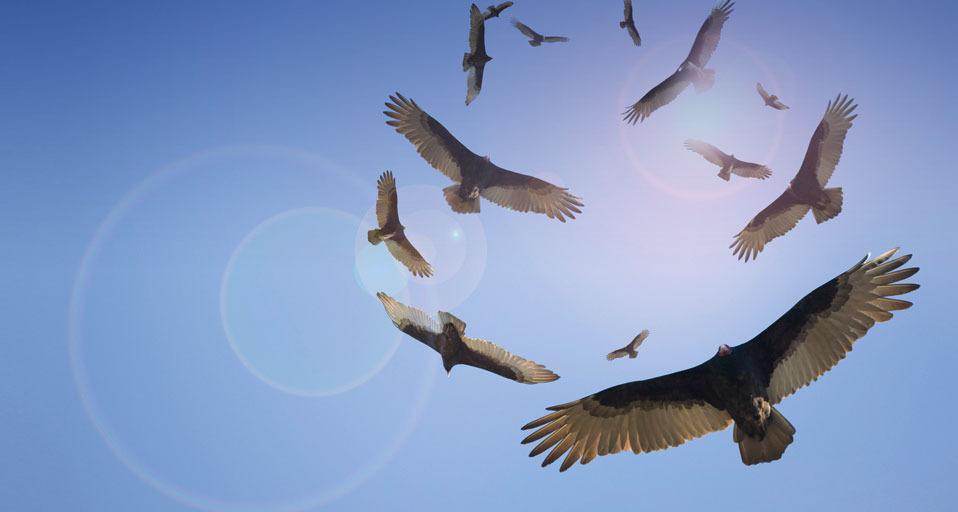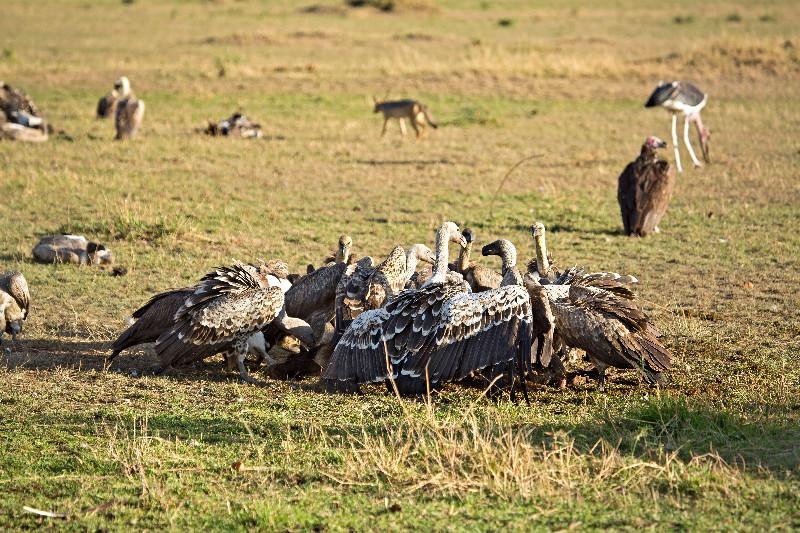The first image is the image on the left, the second image is the image on the right. Evaluate the accuracy of this statement regarding the images: "All vultures in one image are off the ground.". Is it true? Answer yes or no. Yes. The first image is the image on the left, the second image is the image on the right. For the images displayed, is the sentence "In 1 of the images, at least 1 bird is flying." factually correct? Answer yes or no. Yes. 